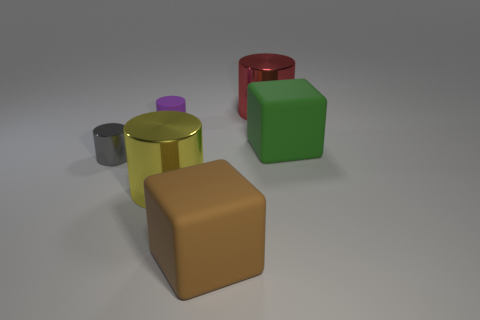What is the shape of the metal thing that is in front of the rubber cylinder and right of the purple matte object?
Keep it short and to the point. Cylinder. Is there another cylinder of the same size as the purple rubber cylinder?
Keep it short and to the point. Yes. How many things are either objects to the left of the small purple matte object or gray cubes?
Your answer should be compact. 1. Does the large brown cube have the same material as the big thing that is on the right side of the large red thing?
Provide a succinct answer. Yes. How many other things are the same shape as the tiny purple thing?
Offer a terse response. 3. How many objects are either large shiny things in front of the big green matte cube or big metal objects in front of the green block?
Your answer should be compact. 1. How many other objects are there of the same color as the tiny rubber object?
Offer a very short reply. 0. Is the number of small matte cylinders on the left side of the gray cylinder less than the number of things right of the tiny purple thing?
Make the answer very short. Yes. What number of brown blocks are there?
Provide a succinct answer. 1. There is a brown object that is the same shape as the green matte object; what is its material?
Your response must be concise. Rubber. 